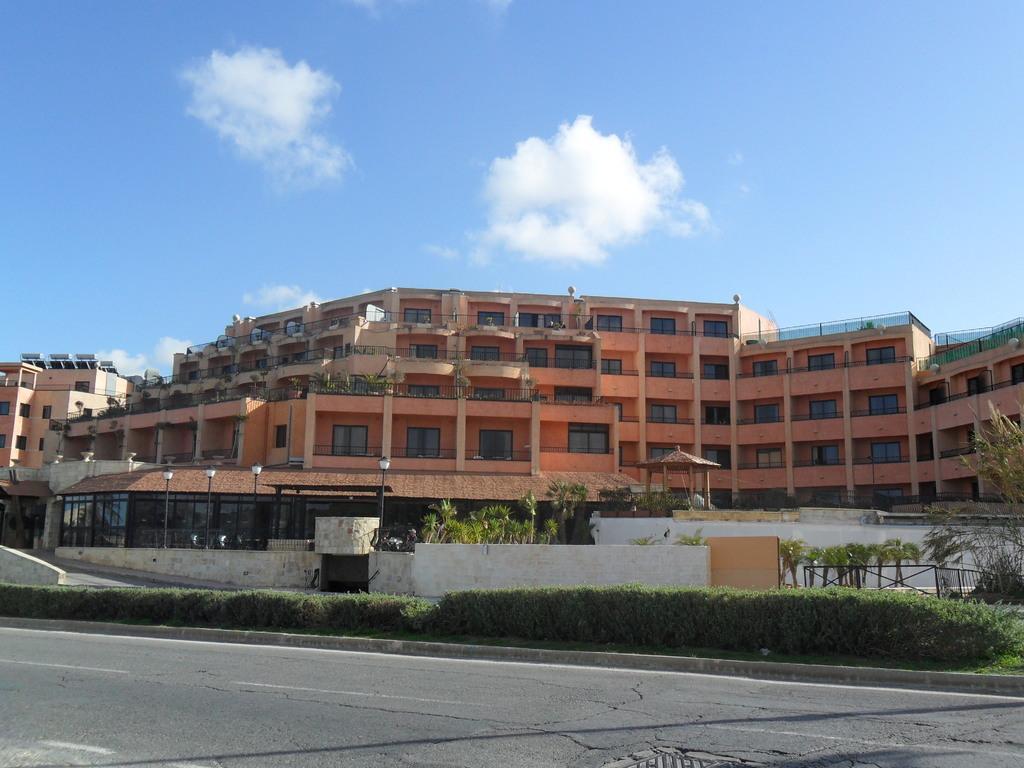Please provide a concise description of this image. In this picture I can see the bushes, street lamps and the road in the middle, in the background there are buildings, at the top I can see the sky. 